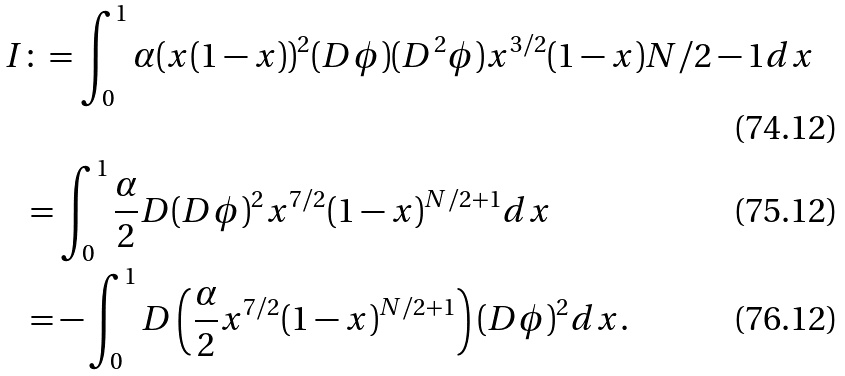<formula> <loc_0><loc_0><loc_500><loc_500>I & \colon = \int _ { 0 } ^ { 1 } \alpha ( x ( 1 - x ) ) ^ { 2 } ( D \phi ) ( D ^ { 2 } \phi ) x ^ { 3 / 2 } ( 1 - x ) { N / 2 - 1 } d x \\ & = \int _ { 0 } ^ { 1 } \frac { \alpha } { 2 } D ( D \phi ) ^ { 2 } x ^ { 7 / 2 } ( 1 - x ) ^ { N / 2 + 1 } d x \\ & = - \int _ { 0 } ^ { 1 } D \left ( \frac { \alpha } { 2 } x ^ { 7 / 2 } ( 1 - x ) ^ { N / 2 + 1 } \right ) ( D \phi ) ^ { 2 } d x .</formula> 